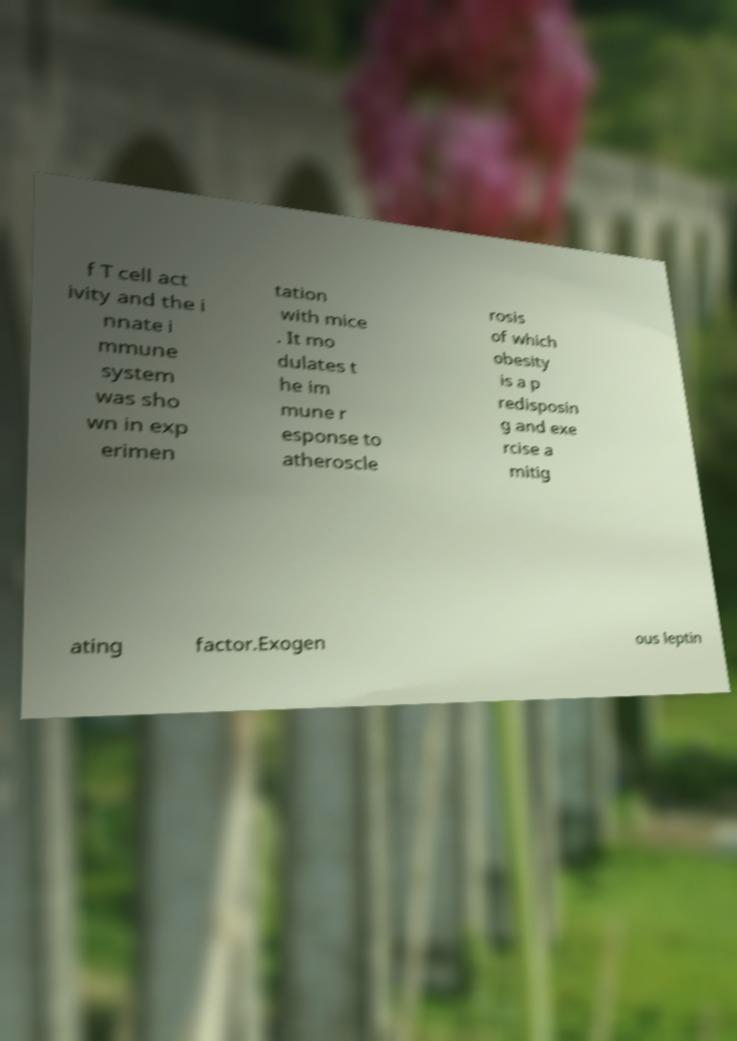What messages or text are displayed in this image? I need them in a readable, typed format. f T cell act ivity and the i nnate i mmune system was sho wn in exp erimen tation with mice . It mo dulates t he im mune r esponse to atheroscle rosis of which obesity is a p redisposin g and exe rcise a mitig ating factor.Exogen ous leptin 